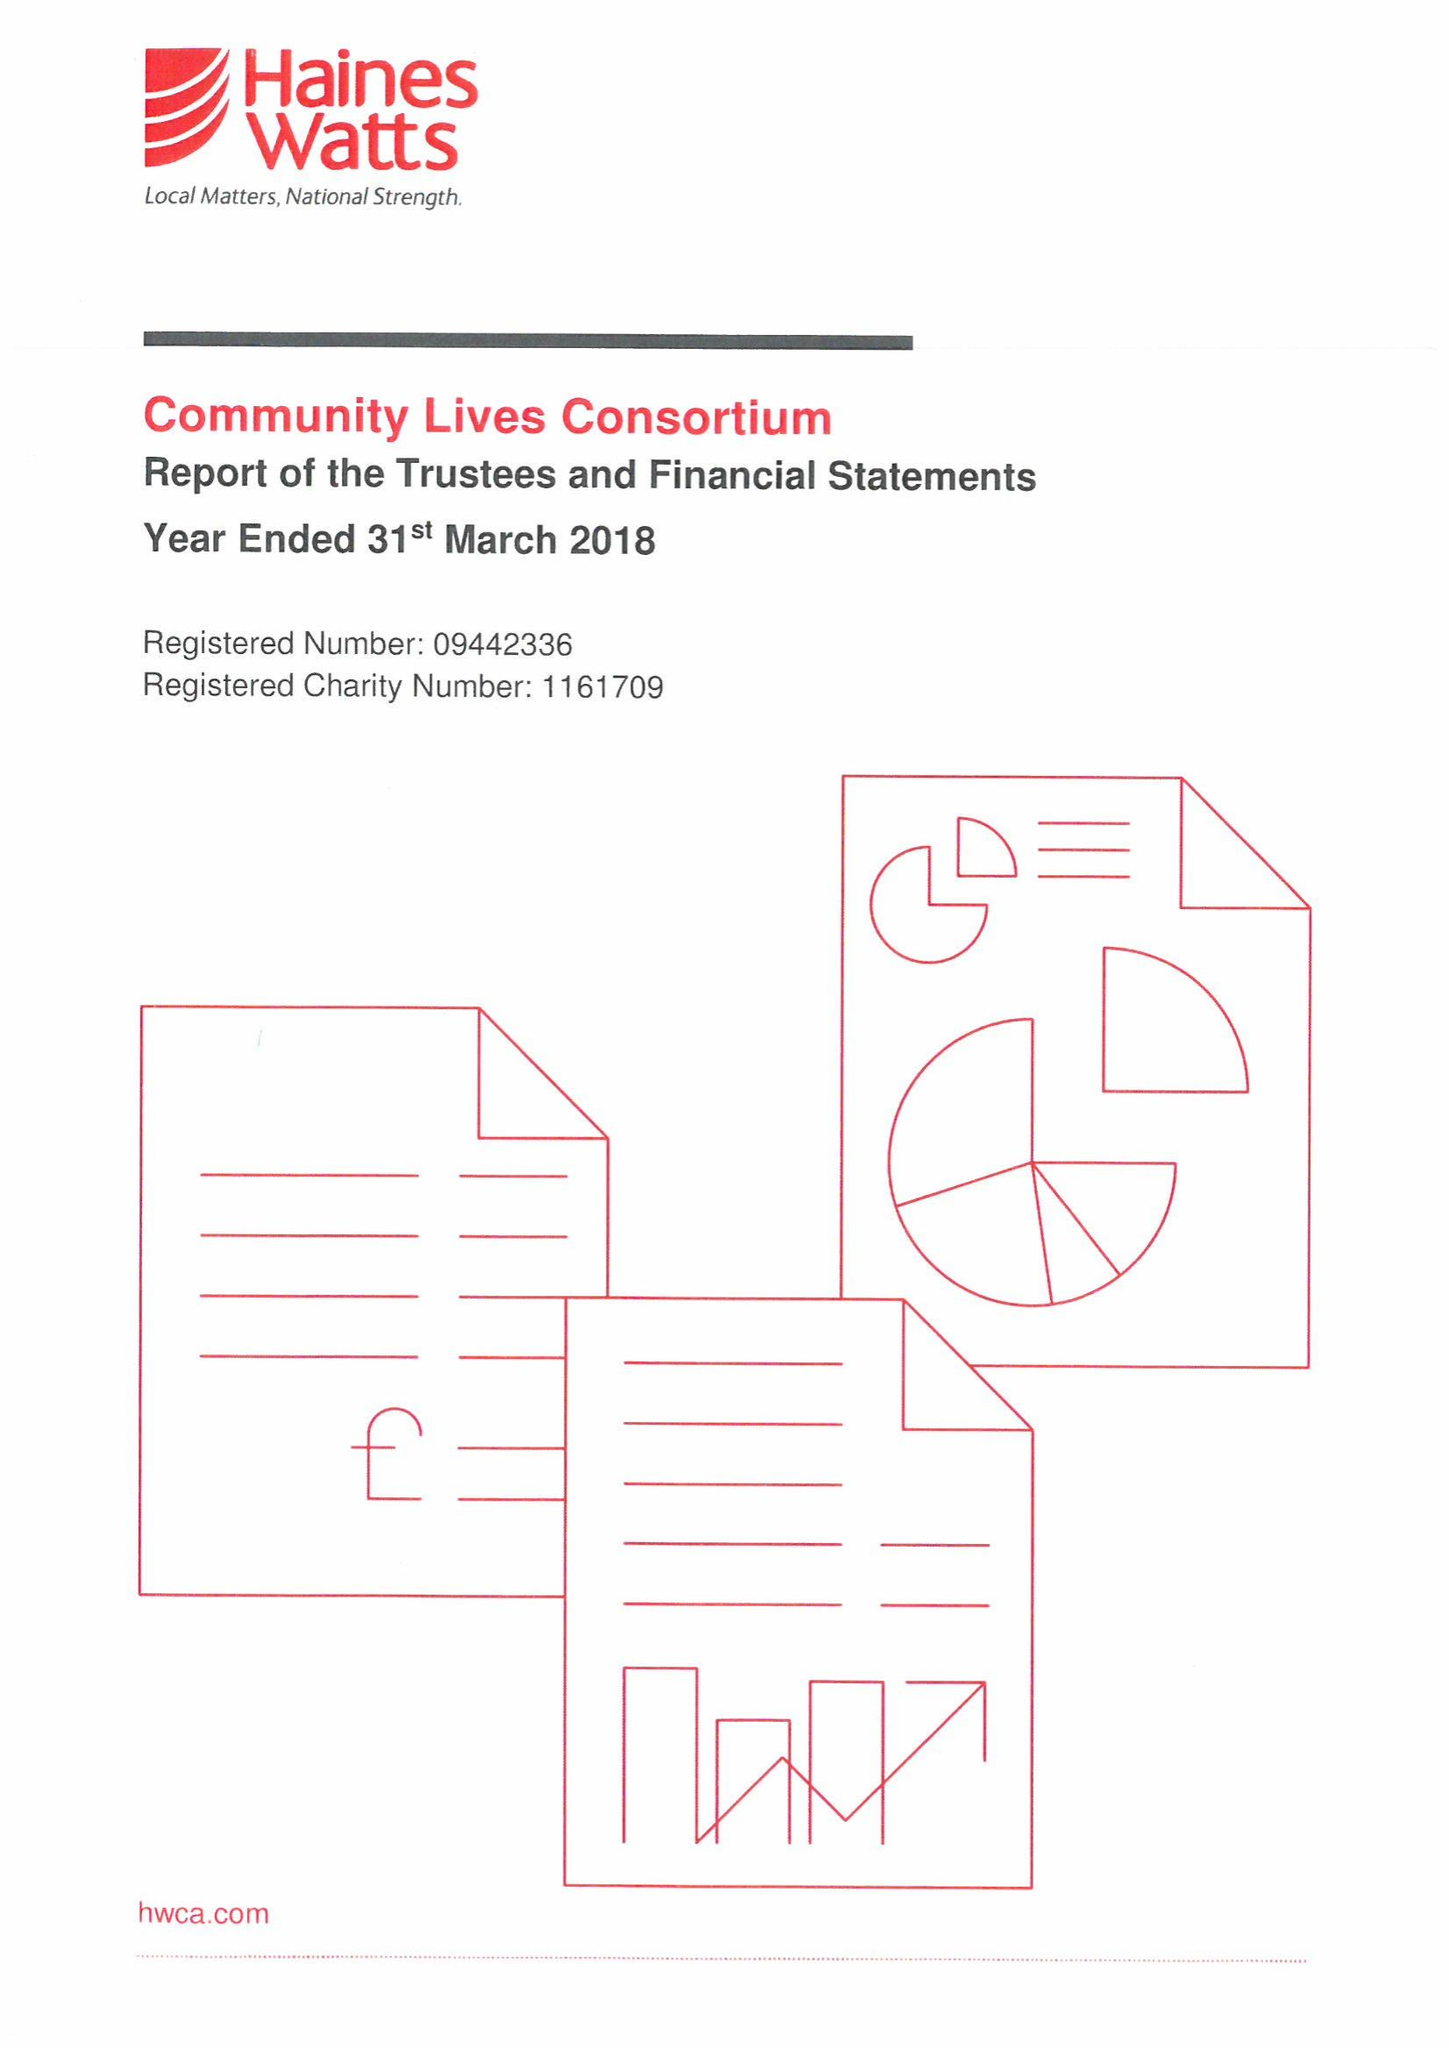What is the value for the charity_name?
Answer the question using a single word or phrase. Community Lives Consortium 